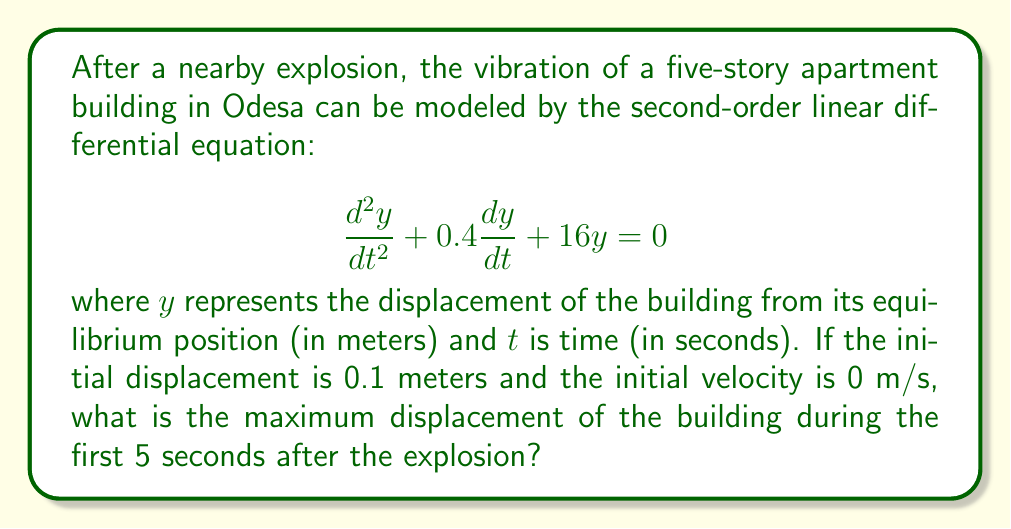Provide a solution to this math problem. To solve this problem, we need to follow these steps:

1) First, we recognize this as a damped harmonic oscillator equation. The general solution for this type of equation is:

   $$y(t) = e^{-\lambda t}(A\cos(\omega t) + B\sin(\omega t))$$

   where $\lambda = 0.2$ (half of the coefficient of $\frac{dy}{dt}$) and $\omega = \sqrt{16 - \lambda^2} = \sqrt{15.96} \approx 3.995$.

2) We need to find $A$ and $B$ using the initial conditions:
   
   $y(0) = 0.1$ and $y'(0) = 0$

3) From $y(0) = 0.1$, we get:
   
   $$0.1 = A$$

4) From $y'(0) = 0$, we get:
   
   $$0 = -0.2A + 3.995B$$
   $$B = \frac{0.2A}{3.995} \approx 0.05006$$

5) So our solution is:

   $$y(t) = e^{-0.2t}(0.1\cos(3.995t) + 0.05006\sin(3.995t))$$

6) To find the maximum displacement in the first 5 seconds, we need to find the maximum absolute value of this function in the interval $[0, 5]$. This can be done numerically, as an analytical solution is complex.

7) Using a numerical method (like plotting or using a computer algebra system), we find that the maximum absolute displacement occurs at approximately $t = 0$ and is equal to the initial displacement, 0.1 meters.
Answer: The maximum displacement of the building during the first 5 seconds after the explosion is 0.1 meters. 